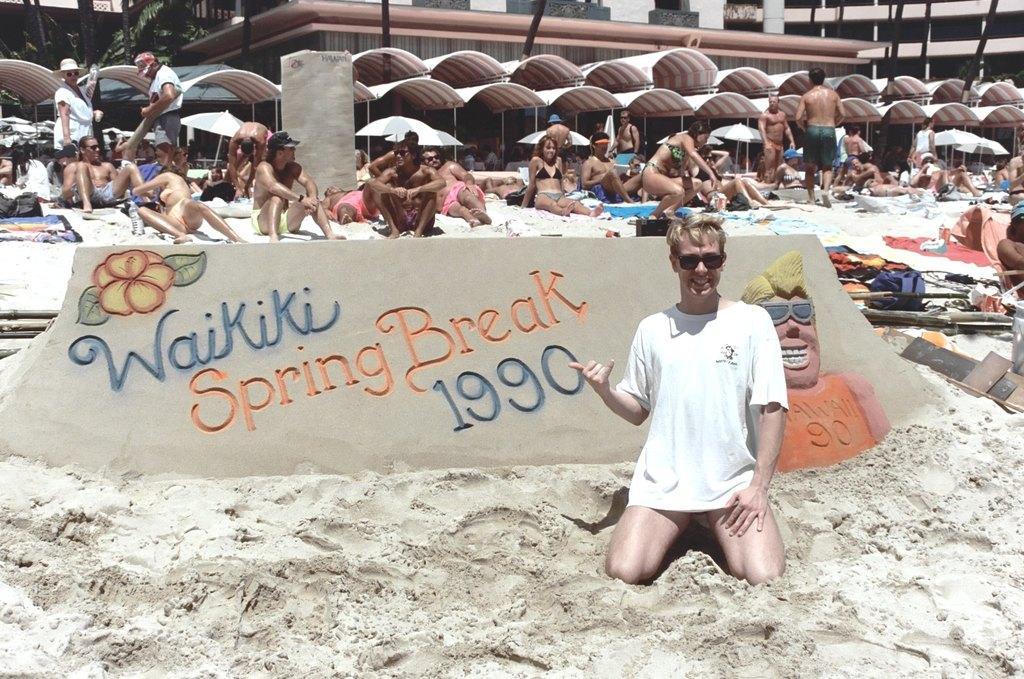Describe this image in one or two sentences. In this picture I can see there is a person sitting on the sand and there is something written in the backdrop. There are few people lying n the sand behind it and there are few trees and a building on to right. 